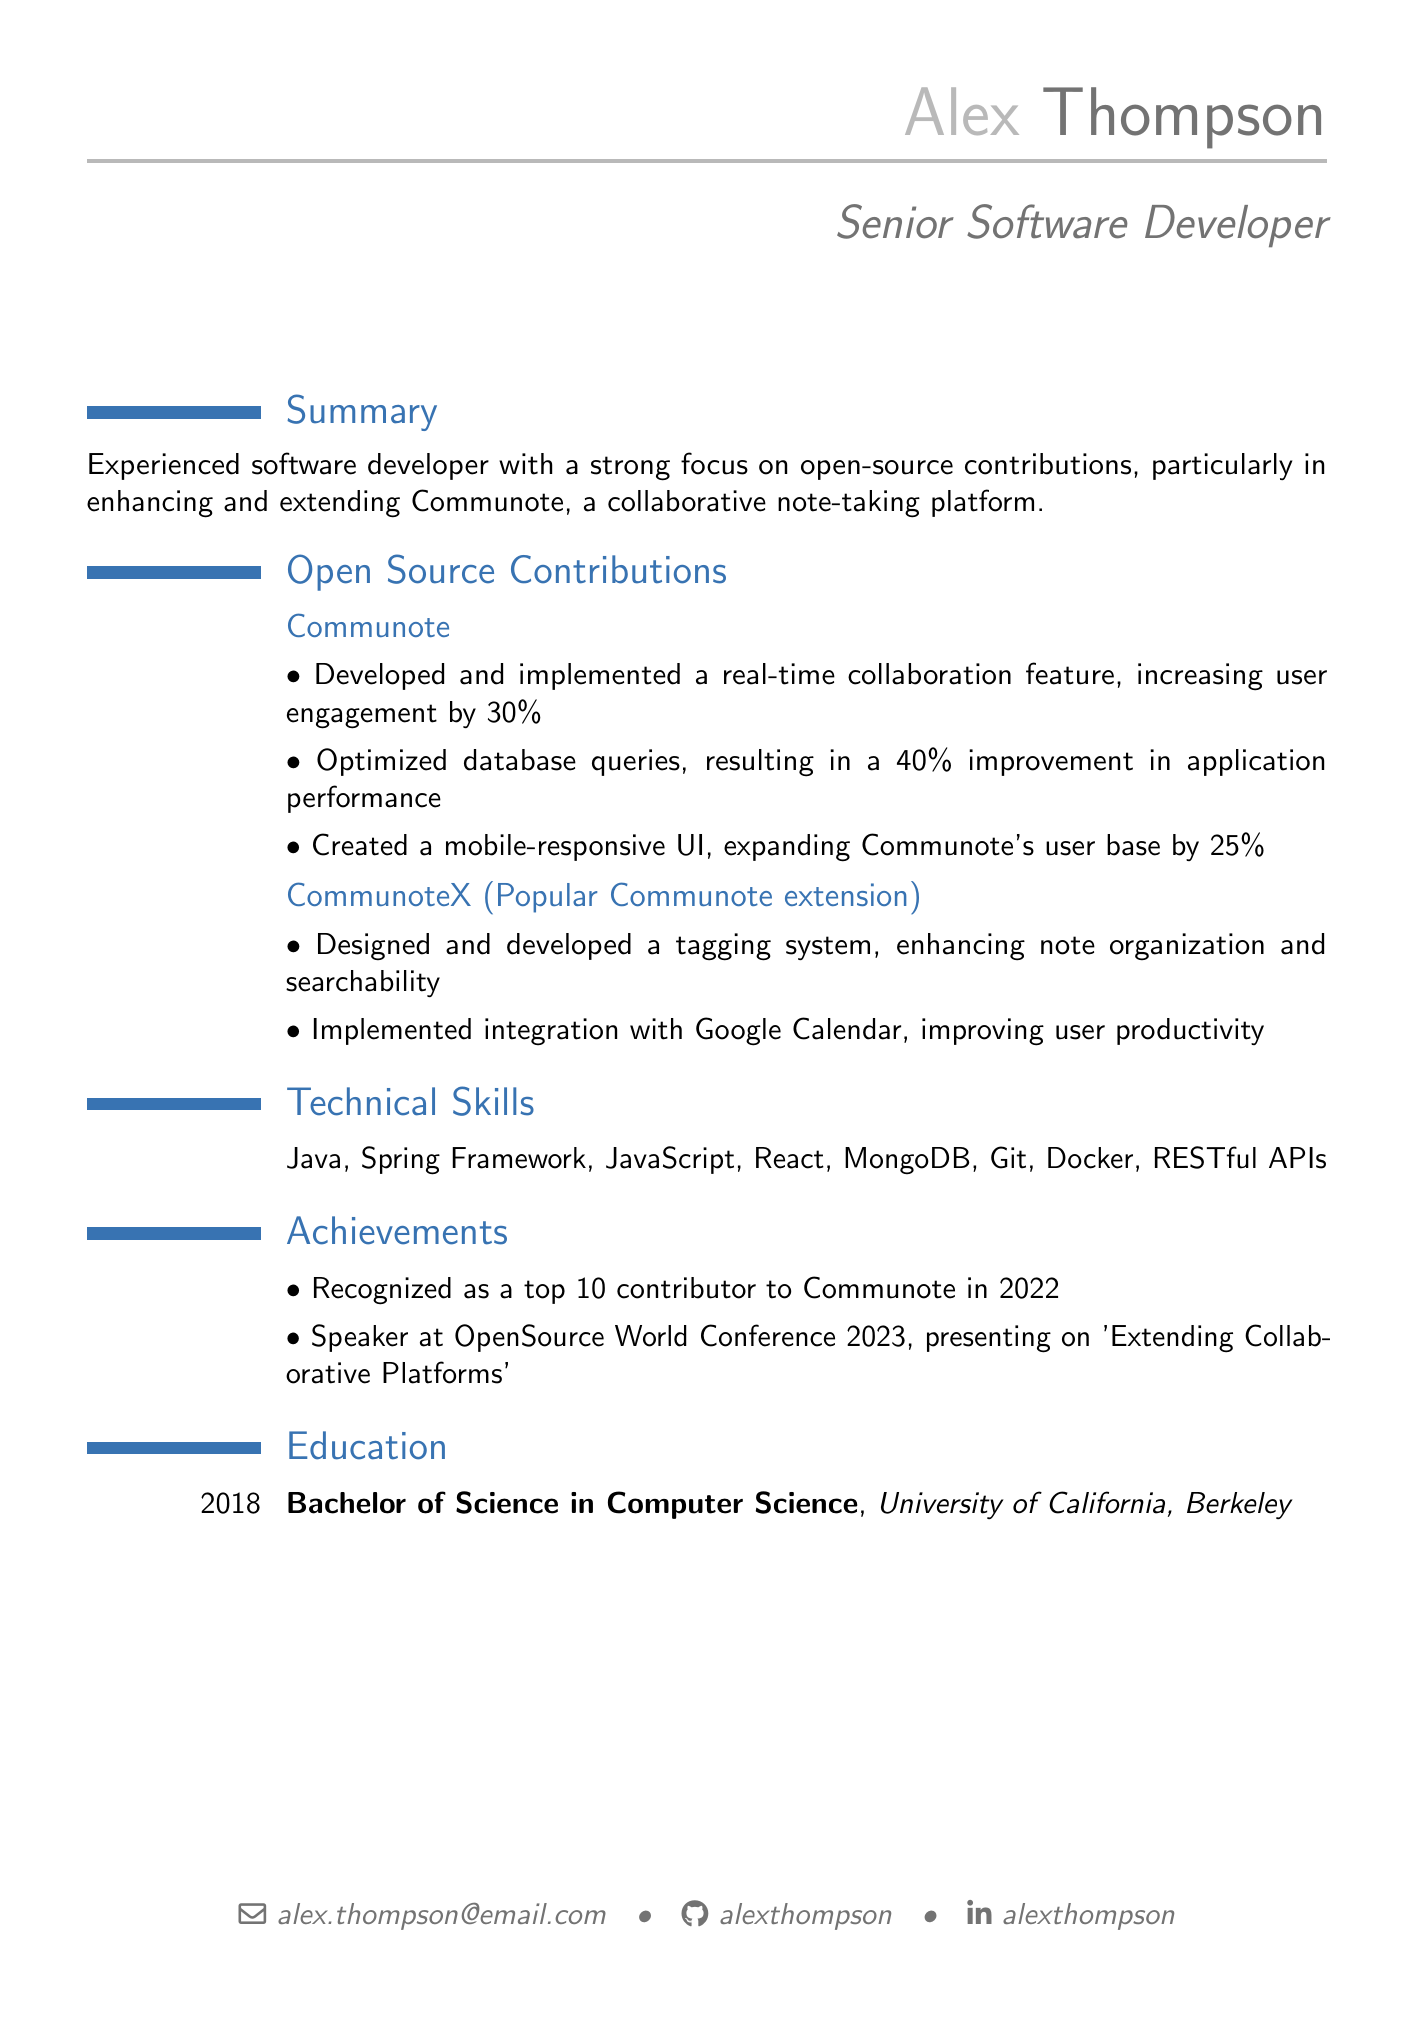what is the name of the individual? The name of the individual as listed in the document is Alex Thompson.
Answer: Alex Thompson what is the title of the CV? The title of the CV states the individual's professional status, which is Senior Software Developer.
Answer: Senior Software Developer how many contributions to Communote are listed? The document lists three specific contributions made to Communote.
Answer: 3 what percentage improvement was achieved by optimizing database queries? The document specifies that there was a 40% improvement in application performance due to the optimization of database queries.
Answer: 40% which university did Alex attend? The document indicates that Alex attended the University of California, Berkeley.
Answer: University of California, Berkeley what year did Alex graduate? The document states the graduation year as 2018.
Answer: 2018 what is one of the achievements listed? The document highlights being recognized as a top 10 contributor to Communote in 2022 as one of the achievements.
Answer: Top 10 contributor to Communote in 2022 what is the primary focus of Alex's open-source contributions? The summary in the document indicates that the primary focus is on enhancing and extending Communote.
Answer: Enhancing and extending Communote how many contributions were made to CommunoteX? The document mentions two contributions made to the CommunoteX extension.
Answer: 2 